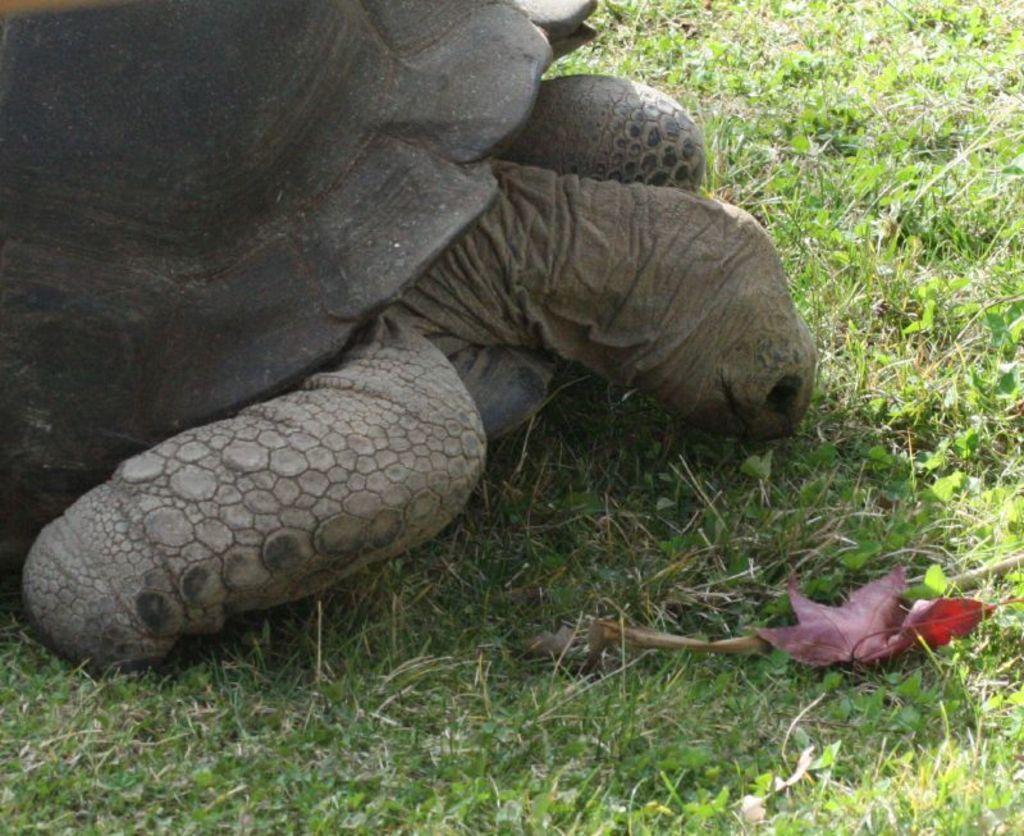Can you describe this image briefly? In this image there is a tortoise on the surface of the grass. 